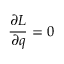<formula> <loc_0><loc_0><loc_500><loc_500>{ \frac { \partial L } { \partial q } } = 0</formula> 